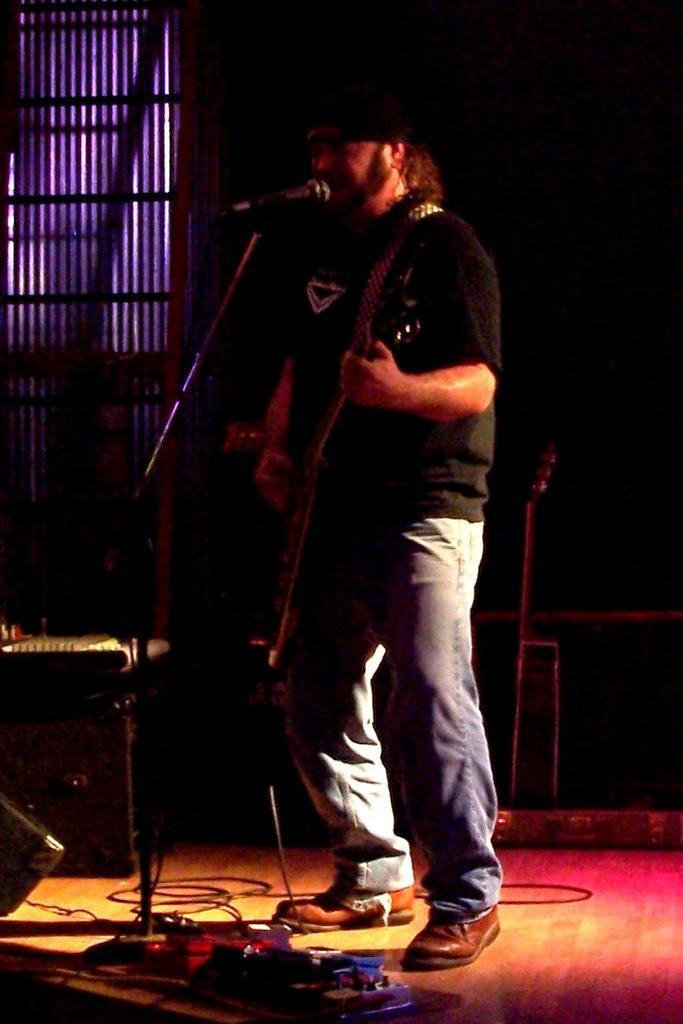In one or two sentences, can you explain what this image depicts? In this image in the center there is one man who is standing and he is playing a guitar, in front of him there is one mike. At the bottom there are some wires, and in the background there are some musical instruments and window. 